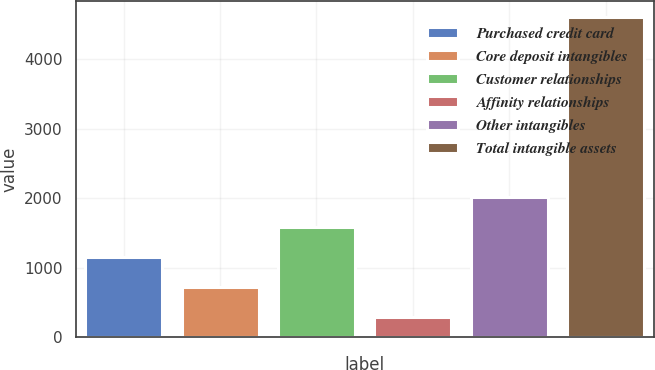Convert chart. <chart><loc_0><loc_0><loc_500><loc_500><bar_chart><fcel>Purchased credit card<fcel>Core deposit intangibles<fcel>Customer relationships<fcel>Affinity relationships<fcel>Other intangibles<fcel>Total intangible assets<nl><fcel>1148<fcel>715<fcel>1581<fcel>282<fcel>2014<fcel>4612<nl></chart> 